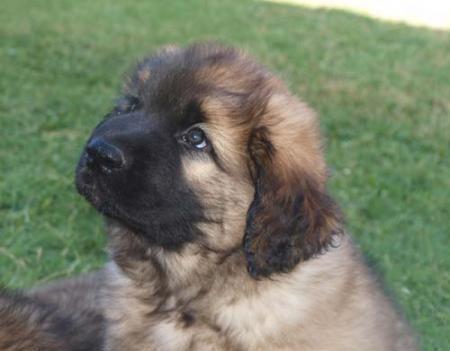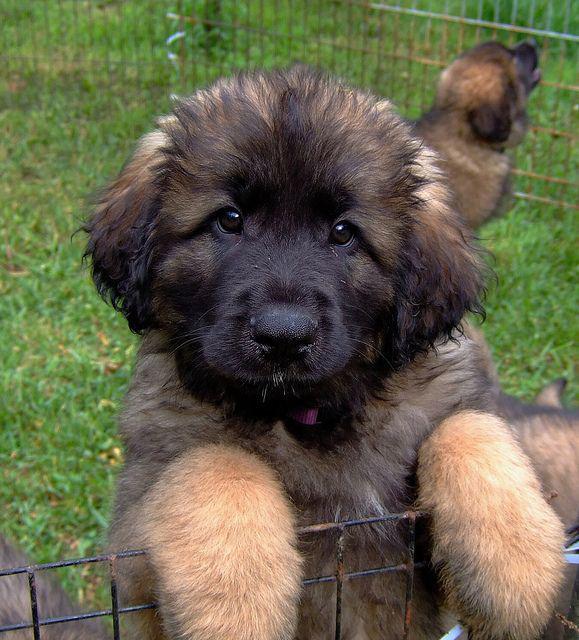The first image is the image on the left, the second image is the image on the right. Examine the images to the left and right. Is the description "There is at least one dog in the right image." accurate? Answer yes or no. Yes. The first image is the image on the left, the second image is the image on the right. Evaluate the accuracy of this statement regarding the images: "An image shows at least one dog that is walking forward, with one front paw in front of the other.". Is it true? Answer yes or no. No. 